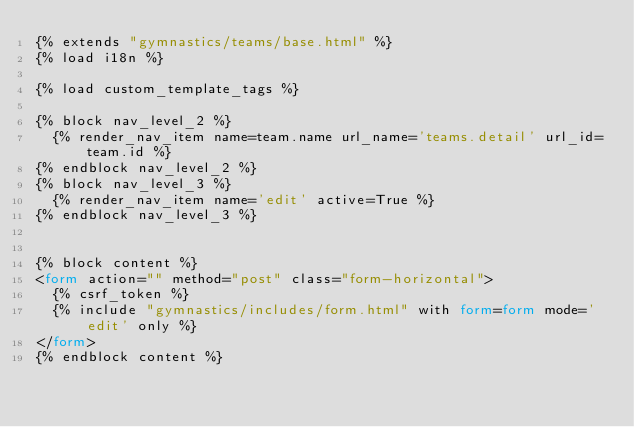<code> <loc_0><loc_0><loc_500><loc_500><_HTML_>{% extends "gymnastics/teams/base.html" %}
{% load i18n %}

{% load custom_template_tags %}
                  
{% block nav_level_2 %}
  {% render_nav_item name=team.name url_name='teams.detail' url_id=team.id %}
{% endblock nav_level_2 %}
{% block nav_level_3 %}
  {% render_nav_item name='edit' active=True %}
{% endblock nav_level_3 %}


{% block content %}
<form action="" method="post" class="form-horizontal">
  {% csrf_token %}
  {% include "gymnastics/includes/form.html" with form=form mode='edit' only %}
</form>
{% endblock content %}</code> 